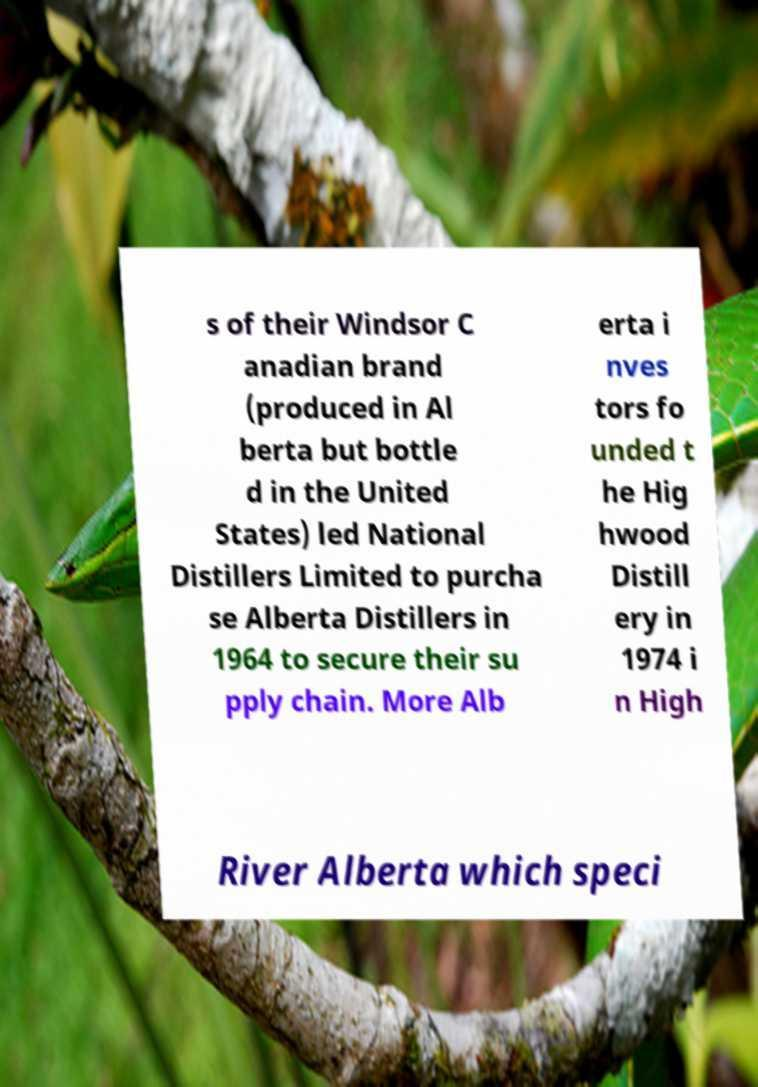What messages or text are displayed in this image? I need them in a readable, typed format. s of their Windsor C anadian brand (produced in Al berta but bottle d in the United States) led National Distillers Limited to purcha se Alberta Distillers in 1964 to secure their su pply chain. More Alb erta i nves tors fo unded t he Hig hwood Distill ery in 1974 i n High River Alberta which speci 